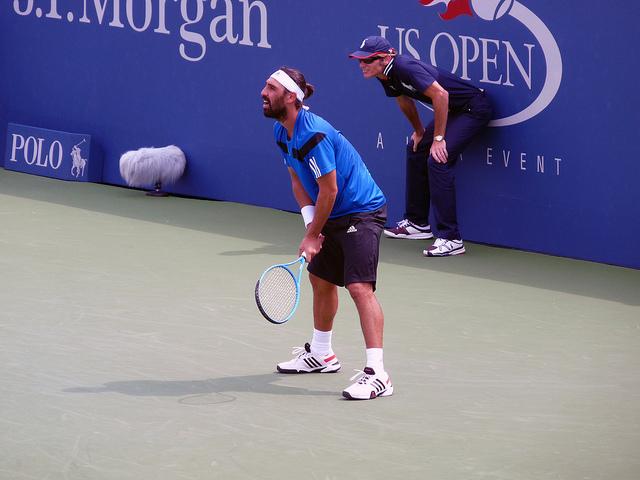What bank is sponsoring the match?
Write a very short answer. Jp morgan. What is the brand on the right?
Quick response, please. Us open. Is this man holding a tennis racket?
Write a very short answer. Yes. Is this a tennis match at the US Open?
Give a very brief answer. Yes. 